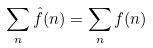Convert formula to latex. <formula><loc_0><loc_0><loc_500><loc_500>\sum _ { n } \hat { f } ( n ) = \sum _ { n } f ( n )</formula> 